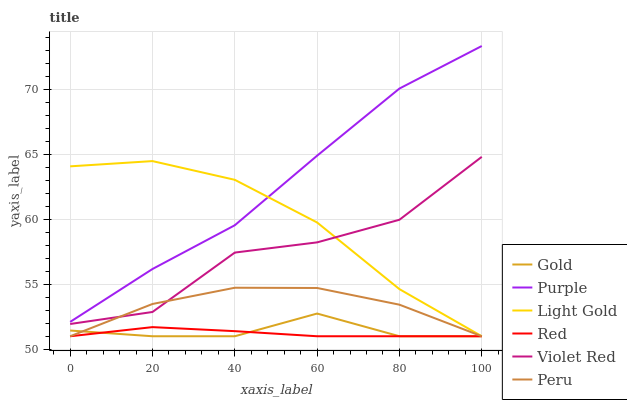Does Gold have the minimum area under the curve?
Answer yes or no. No. Does Gold have the maximum area under the curve?
Answer yes or no. No. Is Gold the smoothest?
Answer yes or no. No. Is Gold the roughest?
Answer yes or no. No. Does Purple have the lowest value?
Answer yes or no. No. Does Gold have the highest value?
Answer yes or no. No. Is Peru less than Purple?
Answer yes or no. Yes. Is Violet Red greater than Gold?
Answer yes or no. Yes. Does Peru intersect Purple?
Answer yes or no. No. 